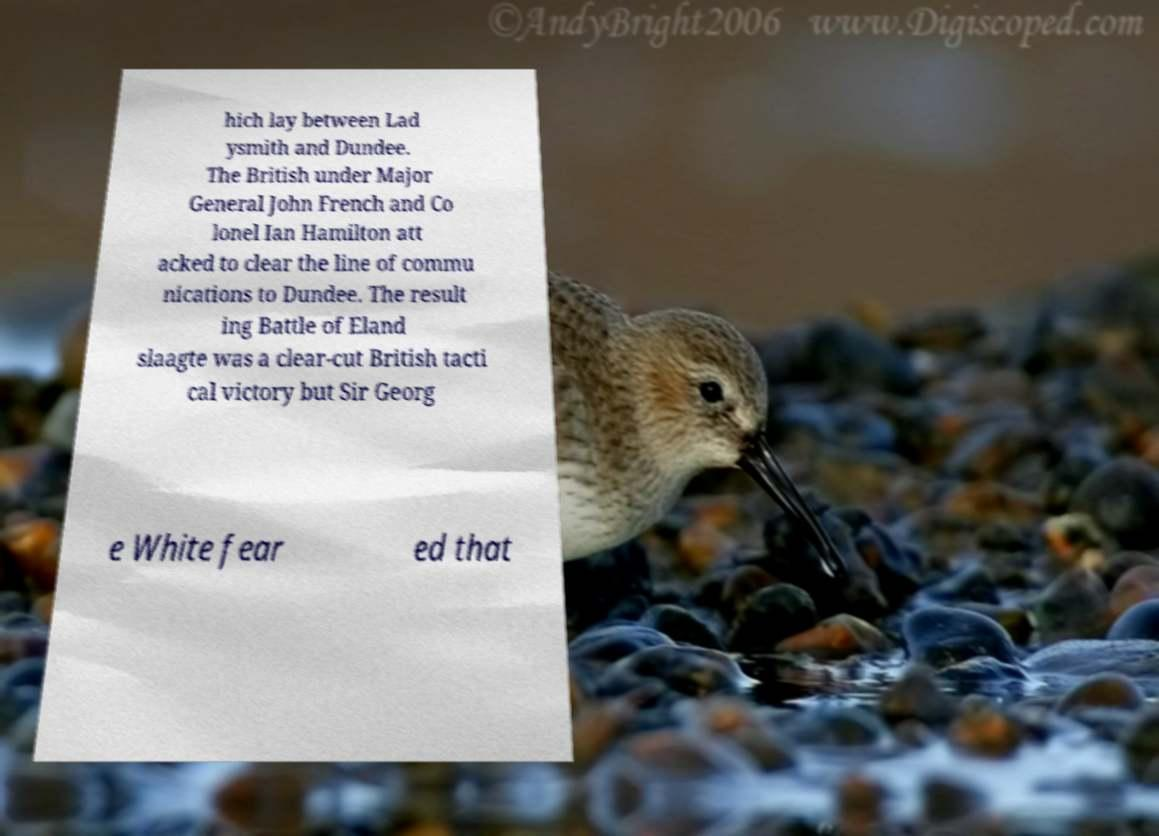Can you accurately transcribe the text from the provided image for me? hich lay between Lad ysmith and Dundee. The British under Major General John French and Co lonel Ian Hamilton att acked to clear the line of commu nications to Dundee. The result ing Battle of Eland slaagte was a clear-cut British tacti cal victory but Sir Georg e White fear ed that 